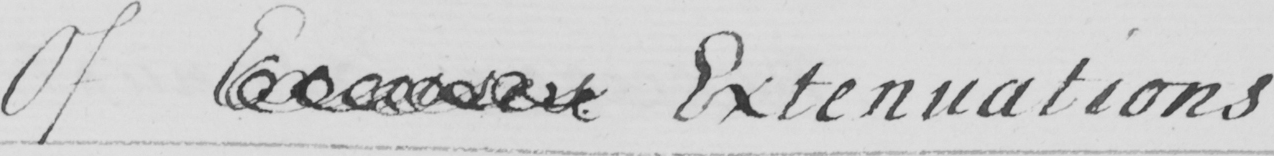What does this handwritten line say? Of Excuses Extenuations 